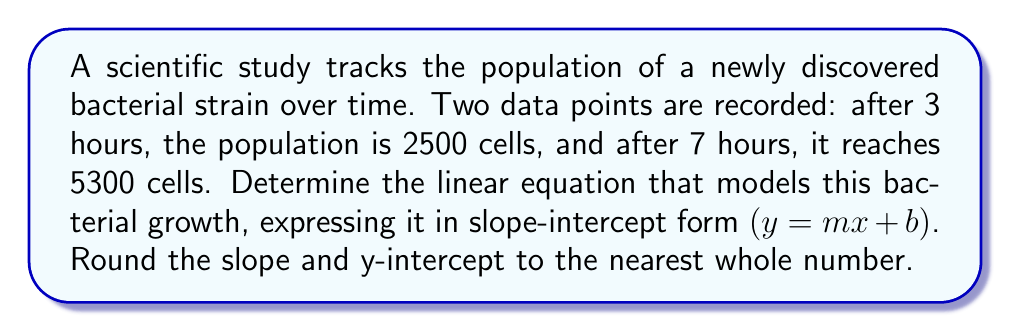Show me your answer to this math problem. To find the equation of a line passing through two points, we'll use the point-slope form and then convert it to slope-intercept form. Let's approach this step-by-step:

1) First, let's identify our two points:
   $(x_1, y_1) = (3, 2500)$ and $(x_2, y_2) = (7, 5300)$

2) Calculate the slope $(m)$ using the slope formula:
   $$m = \frac{y_2 - y_1}{x_2 - x_1} = \frac{5300 - 2500}{7 - 3} = \frac{2800}{4} = 700$$

3) Now we have the slope, we can use either point to find the y-intercept. Let's use $(3, 2500)$:
   $$y = mx + b$$
   $$2500 = 700(3) + b$$
   $$2500 = 2100 + b$$
   $$b = 2500 - 2100 = 400$$

4) Therefore, the equation in slope-intercept form is:
   $$y = 700x + 400$$

This equation models the bacterial population $(y)$ as a function of time in hours $(x)$.
Answer: $y = 700x + 400$ 